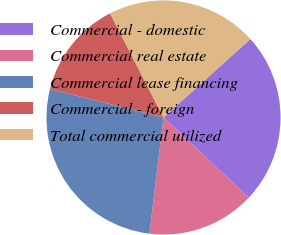Convert chart to OTSL. <chart><loc_0><loc_0><loc_500><loc_500><pie_chart><fcel>Commercial - domestic<fcel>Commercial real estate<fcel>Commercial lease financing<fcel>Commercial - foreign<fcel>Total commercial utilized<nl><fcel>23.7%<fcel>14.91%<fcel>26.99%<fcel>13.54%<fcel>20.86%<nl></chart> 